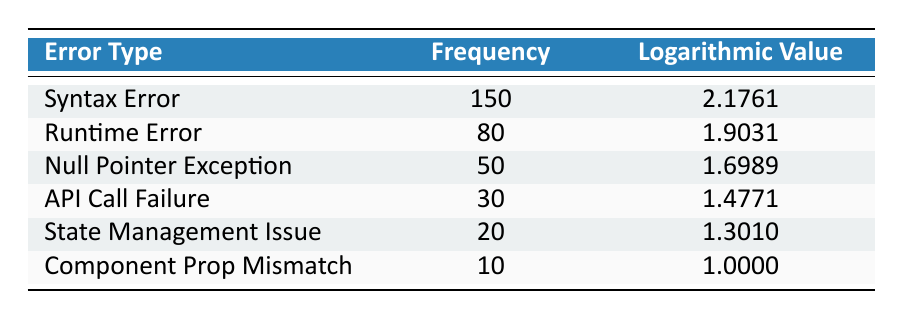What is the frequency of Syntax Errors? Referring to the table, the frequency column shows that there are 150 occurrences of Syntax Errors.
Answer: 150 Which error type has the lowest frequency? By examining the frequency column, Component Prop Mismatch has the lowest frequency with a count of 10.
Answer: Component Prop Mismatch What is the sum of frequencies for Runtime Error and Null Pointer Exception? The frequency of Runtime Error is 80 and for Null Pointer Exception is 50. Adding them together gives 80 + 50 = 130.
Answer: 130 Is there an error type with a logarithmic value greater than 2? Looking at the logarithmic value column, only Syntax Error has a value of 2.1761, which is greater than 2. Thus, the answer is yes.
Answer: Yes What is the average logarithmic value of all error types in the table? To find the average, we sum all the logarithmic values: 2.1761 + 1.9031 + 1.6989 + 1.4771 + 1.3010 + 1.0000 = 9.5562. There are 6 error types, so we divide the total by 6: 9.5562 / 6 = 1.5927.
Answer: 1.5927 Which error type has a logarithmic value closest to 1.5? Comparing the logarithmic values, API Call Failure (1.4771) is the nearest value to 1.5 when all are considered.
Answer: API Call Failure What is the difference in frequency between the most common and the least common error types? The most frequent error type is Syntax Error (150) and the least is Component Prop Mismatch (10). The difference is 150 - 10 = 140.
Answer: 140 Are there more Syntax Errors than total of the other error types combined? The total frequency of all error types except Syntax Error (80 + 50 + 30 + 20 + 10 = 190) is compared with Syntax Error (150). Since 150 is less than 190, the answer is no.
Answer: No 